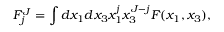<formula> <loc_0><loc_0><loc_500><loc_500>F _ { j } ^ { J } = \int d x _ { 1 } d x _ { 3 } x _ { 1 } ^ { j } x _ { 3 } ^ { J - j } F ( x _ { 1 } , x _ { 3 } ) ,</formula> 